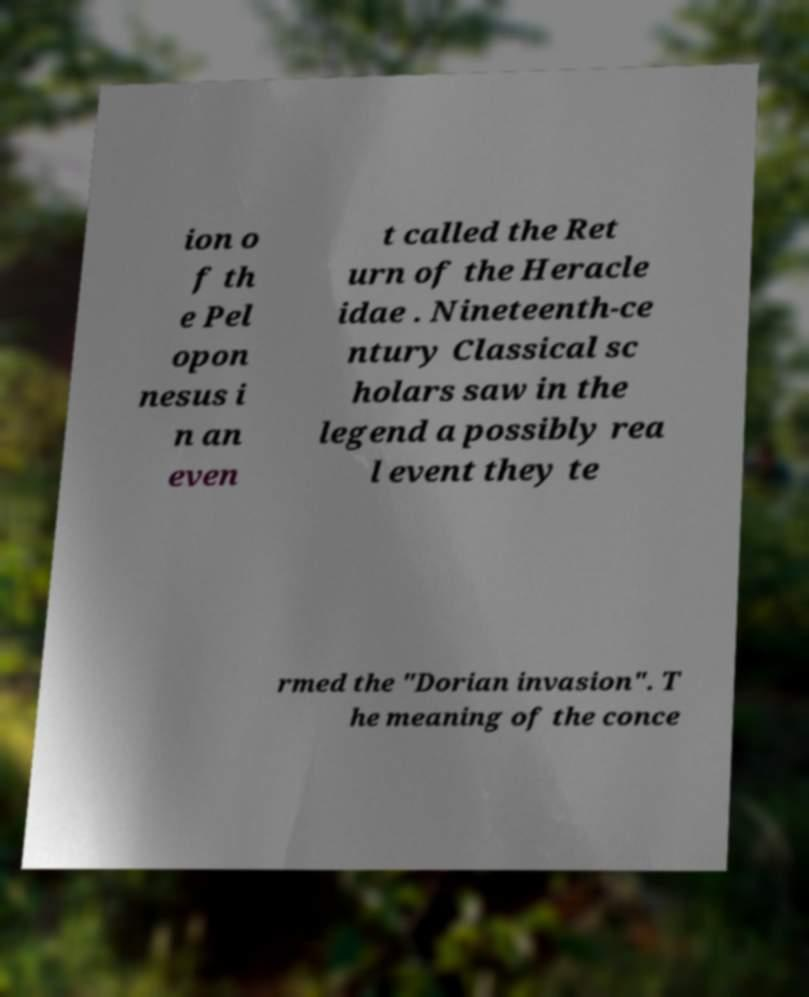Can you accurately transcribe the text from the provided image for me? ion o f th e Pel opon nesus i n an even t called the Ret urn of the Heracle idae . Nineteenth-ce ntury Classical sc holars saw in the legend a possibly rea l event they te rmed the "Dorian invasion". T he meaning of the conce 